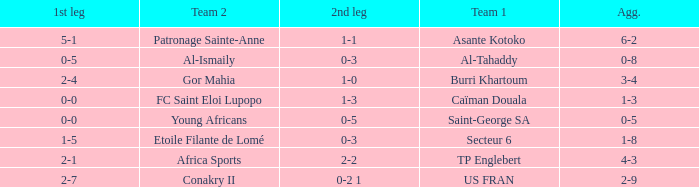What was the 2nd leg score between Patronage Sainte-Anne and Asante Kotoko? 1-1. 